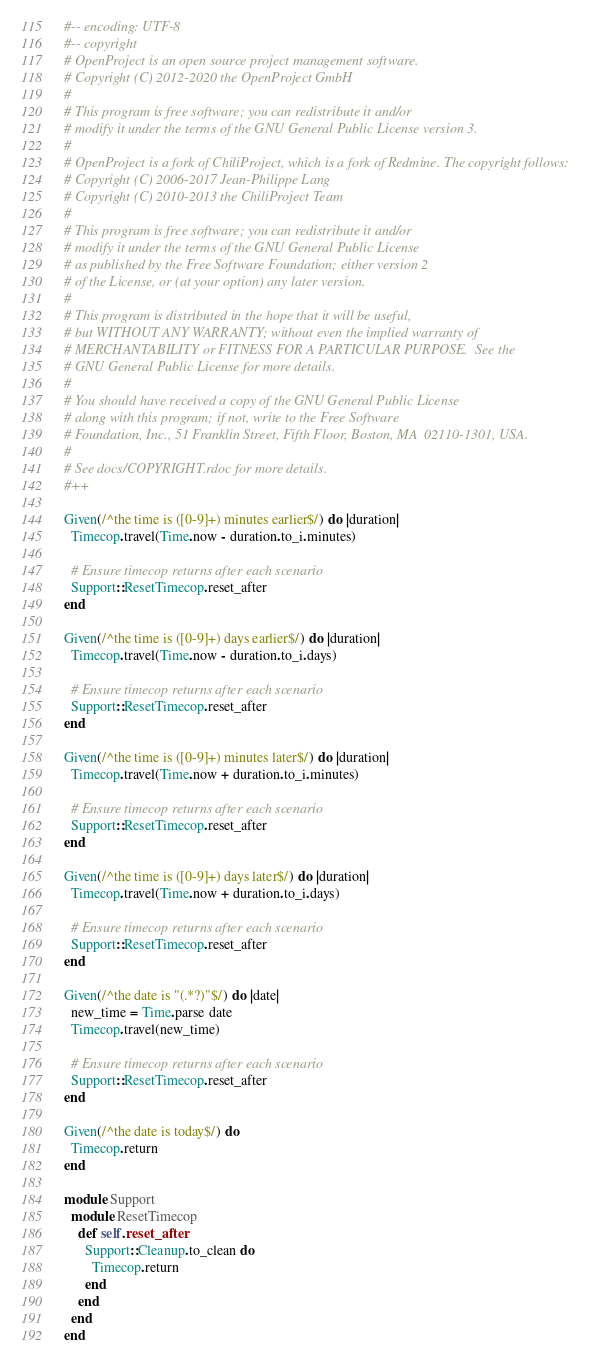<code> <loc_0><loc_0><loc_500><loc_500><_Ruby_>#-- encoding: UTF-8
#-- copyright
# OpenProject is an open source project management software.
# Copyright (C) 2012-2020 the OpenProject GmbH
#
# This program is free software; you can redistribute it and/or
# modify it under the terms of the GNU General Public License version 3.
#
# OpenProject is a fork of ChiliProject, which is a fork of Redmine. The copyright follows:
# Copyright (C) 2006-2017 Jean-Philippe Lang
# Copyright (C) 2010-2013 the ChiliProject Team
#
# This program is free software; you can redistribute it and/or
# modify it under the terms of the GNU General Public License
# as published by the Free Software Foundation; either version 2
# of the License, or (at your option) any later version.
#
# This program is distributed in the hope that it will be useful,
# but WITHOUT ANY WARRANTY; without even the implied warranty of
# MERCHANTABILITY or FITNESS FOR A PARTICULAR PURPOSE.  See the
# GNU General Public License for more details.
#
# You should have received a copy of the GNU General Public License
# along with this program; if not, write to the Free Software
# Foundation, Inc., 51 Franklin Street, Fifth Floor, Boston, MA  02110-1301, USA.
#
# See docs/COPYRIGHT.rdoc for more details.
#++

Given(/^the time is ([0-9]+) minutes earlier$/) do |duration|
  Timecop.travel(Time.now - duration.to_i.minutes)

  # Ensure timecop returns after each scenario
  Support::ResetTimecop.reset_after
end

Given(/^the time is ([0-9]+) days earlier$/) do |duration|
  Timecop.travel(Time.now - duration.to_i.days)

  # Ensure timecop returns after each scenario
  Support::ResetTimecop.reset_after
end

Given(/^the time is ([0-9]+) minutes later$/) do |duration|
  Timecop.travel(Time.now + duration.to_i.minutes)

  # Ensure timecop returns after each scenario
  Support::ResetTimecop.reset_after
end

Given(/^the time is ([0-9]+) days later$/) do |duration|
  Timecop.travel(Time.now + duration.to_i.days)

  # Ensure timecop returns after each scenario
  Support::ResetTimecop.reset_after
end

Given(/^the date is "(.*?)"$/) do |date|
  new_time = Time.parse date
  Timecop.travel(new_time)

  # Ensure timecop returns after each scenario
  Support::ResetTimecop.reset_after
end

Given(/^the date is today$/) do
  Timecop.return
end

module Support
  module ResetTimecop
    def self.reset_after
      Support::Cleanup.to_clean do
        Timecop.return
      end
    end
  end
end
</code> 